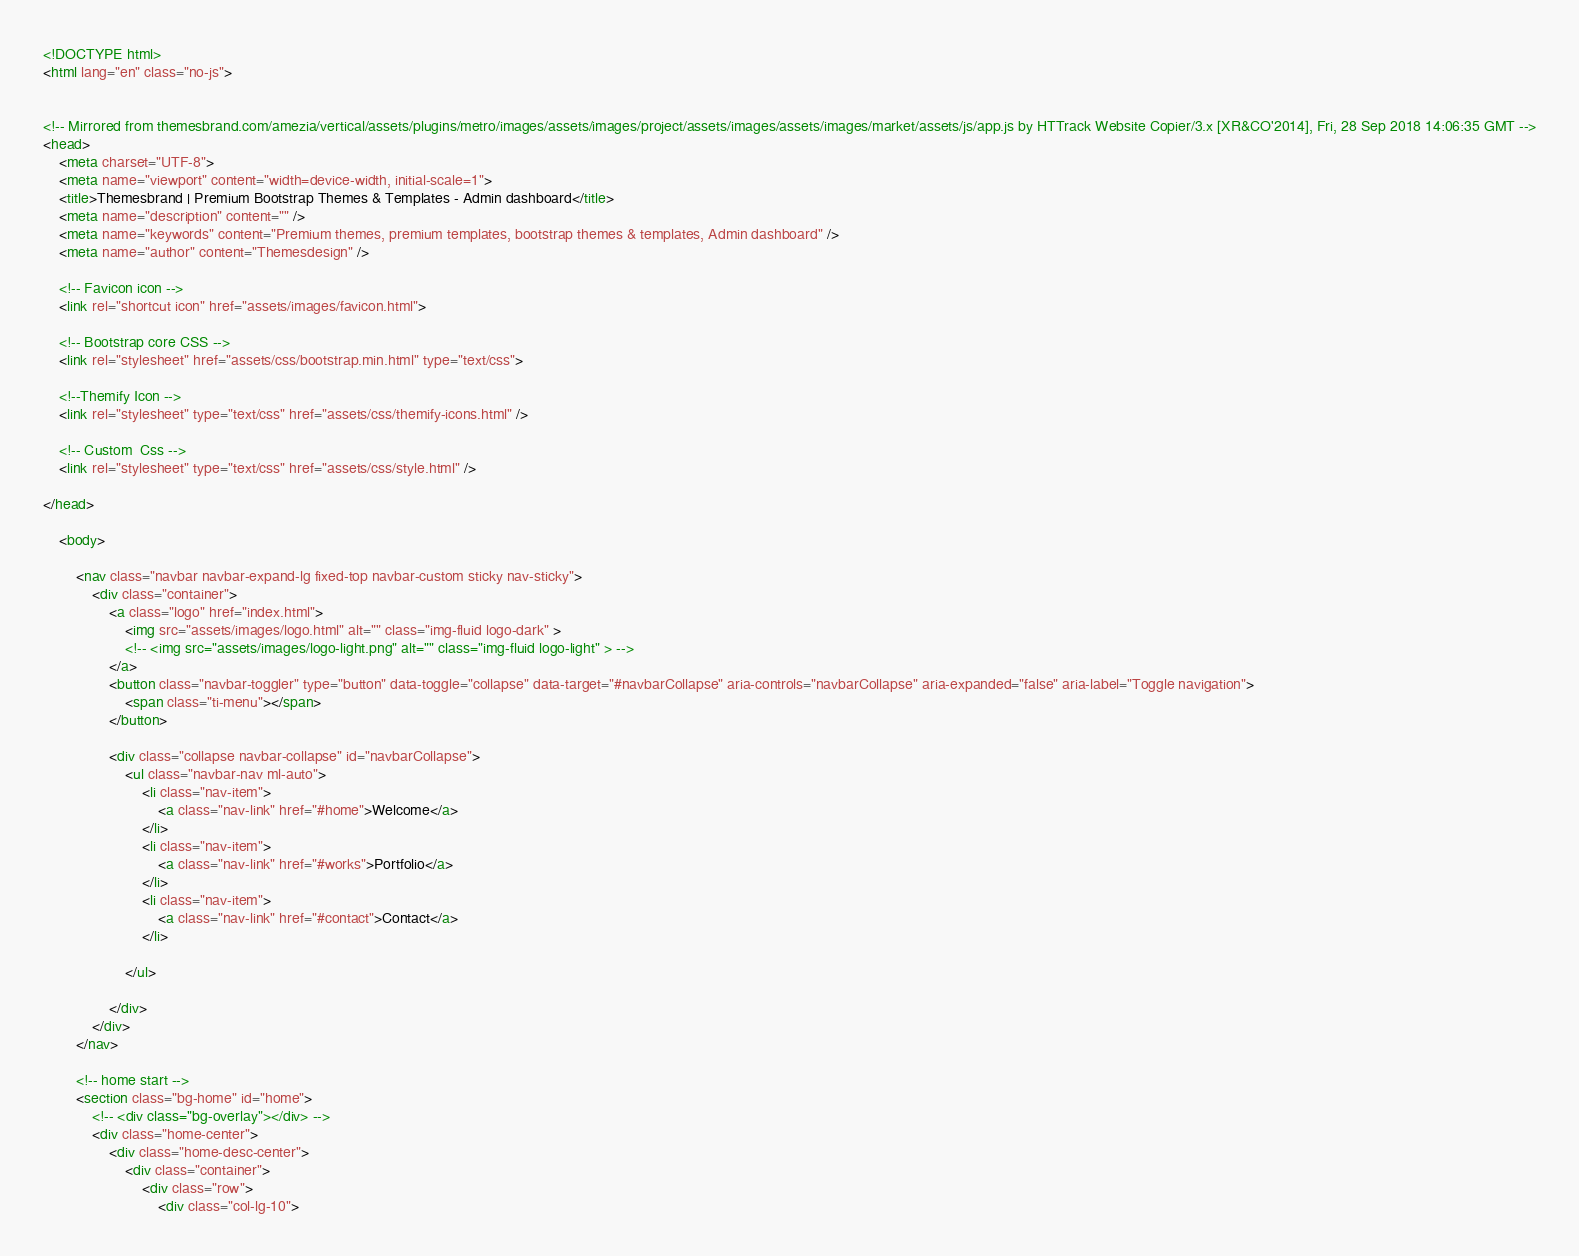<code> <loc_0><loc_0><loc_500><loc_500><_HTML_><!DOCTYPE html>
<html lang="en" class="no-js">


<!-- Mirrored from themesbrand.com/amezia/vertical/assets/plugins/metro/images/assets/images/project/assets/images/assets/images/market/assets/js/app.js by HTTrack Website Copier/3.x [XR&CO'2014], Fri, 28 Sep 2018 14:06:35 GMT -->
<head>
    <meta charset="UTF-8">
    <meta name="viewport" content="width=device-width, initial-scale=1">
    <title>Themesbrand | Premium Bootstrap Themes & Templates - Admin dashboard</title>
    <meta name="description" content="" />
    <meta name="keywords" content="Premium themes, premium templates, bootstrap themes & templates, Admin dashboard" />
    <meta name="author" content="Themesdesign" />

    <!-- Favicon icon -->
    <link rel="shortcut icon" href="assets/images/favicon.html">

    <!-- Bootstrap core CSS -->
    <link rel="stylesheet" href="assets/css/bootstrap.min.html" type="text/css">

    <!--Themify Icon -->
    <link rel="stylesheet" type="text/css" href="assets/css/themify-icons.html" />

    <!-- Custom  Css -->
    <link rel="stylesheet" type="text/css" href="assets/css/style.html" />

</head>

    <body>

        <nav class="navbar navbar-expand-lg fixed-top navbar-custom sticky nav-sticky">
            <div class="container">
                <a class="logo" href="index.html">
                    <img src="assets/images/logo.html" alt="" class="img-fluid logo-dark" >
                    <!-- <img src="assets/images/logo-light.png" alt="" class="img-fluid logo-light" > -->
                </a>
                <button class="navbar-toggler" type="button" data-toggle="collapse" data-target="#navbarCollapse" aria-controls="navbarCollapse" aria-expanded="false" aria-label="Toggle navigation">
                    <span class="ti-menu"></span>
                </button>

                <div class="collapse navbar-collapse" id="navbarCollapse">
                    <ul class="navbar-nav ml-auto">
                        <li class="nav-item">
                            <a class="nav-link" href="#home">Welcome</a>
                        </li>
                        <li class="nav-item">
                            <a class="nav-link" href="#works">Portfolio</a>
                        </li>
                        <li class="nav-item">
                            <a class="nav-link" href="#contact">Contact</a>
                        </li>

                    </ul>

                </div>
            </div>
        </nav>

        <!-- home start -->
        <section class="bg-home" id="home">
            <!-- <div class="bg-overlay"></div> -->
            <div class="home-center">
                <div class="home-desc-center">
                    <div class="container">
                        <div class="row">
                            <div class="col-lg-10"></code> 